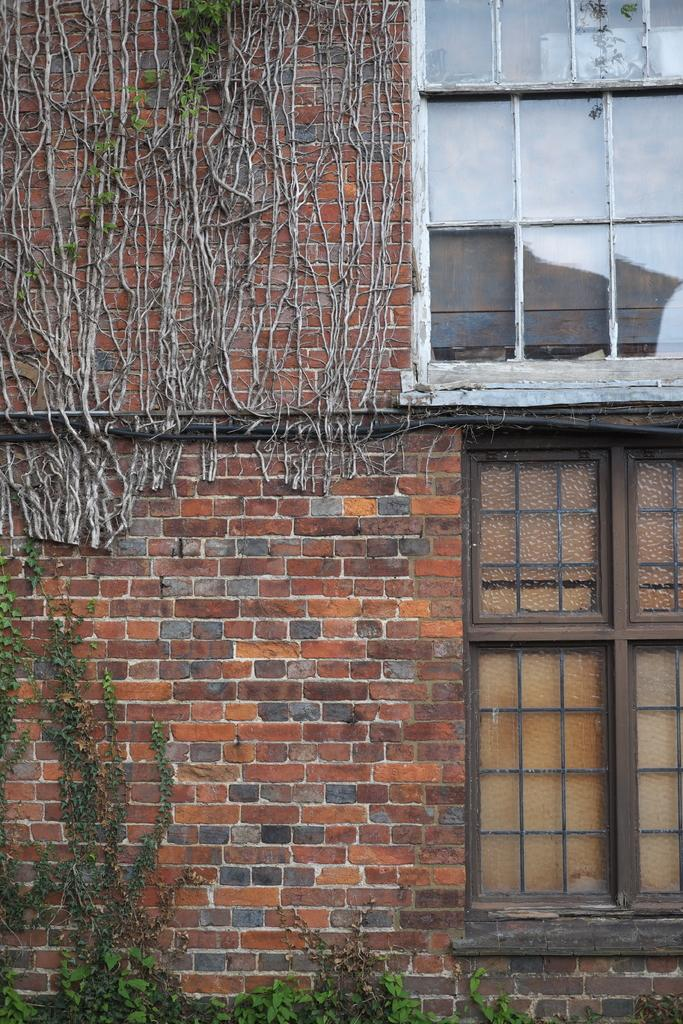What type of structure is visible in the image? There is a brick wall in the image. What is located at the bottom of the wall? There are plants at the bottom of the wall. What can be seen on the right side of the image? There are glass windows on the right side of the image. What type of insect can be seen flying near the bit in the image? There is no insect or bit present in the image. 